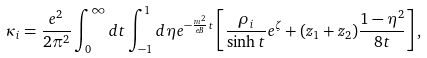<formula> <loc_0><loc_0><loc_500><loc_500>\kappa _ { i } = \frac { e ^ { 2 } } { 2 \pi ^ { 2 } } \int _ { 0 } ^ { \infty } d t \int _ { - 1 } ^ { 1 } d \eta e ^ { - \frac { m ^ { 2 } } { e B } t } \left [ \frac { \rho _ { i } } { \sinh t } e ^ { \zeta } + ( z _ { 1 } + z _ { 2 } ) \frac { 1 - \eta ^ { 2 } } { 8 t } \right ] ,</formula> 